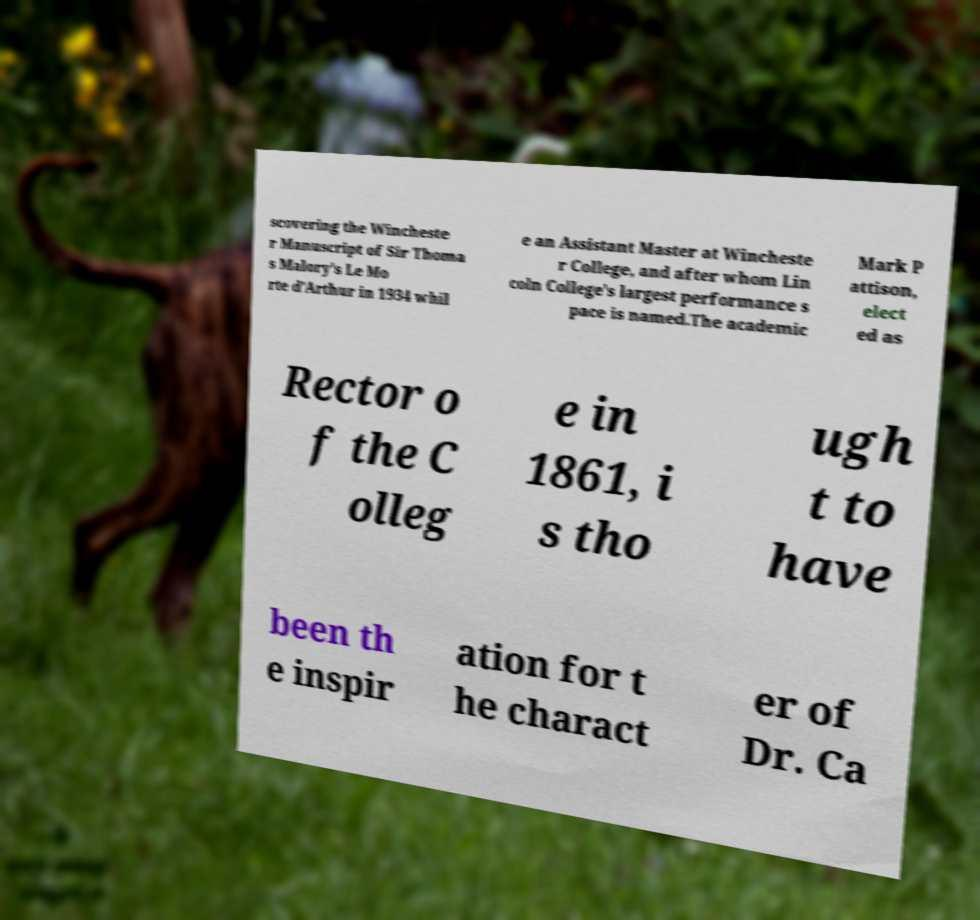Please identify and transcribe the text found in this image. scovering the Wincheste r Manuscript of Sir Thoma s Malory's Le Mo rte d'Arthur in 1934 whil e an Assistant Master at Wincheste r College, and after whom Lin coln College's largest performance s pace is named.The academic Mark P attison, elect ed as Rector o f the C olleg e in 1861, i s tho ugh t to have been th e inspir ation for t he charact er of Dr. Ca 